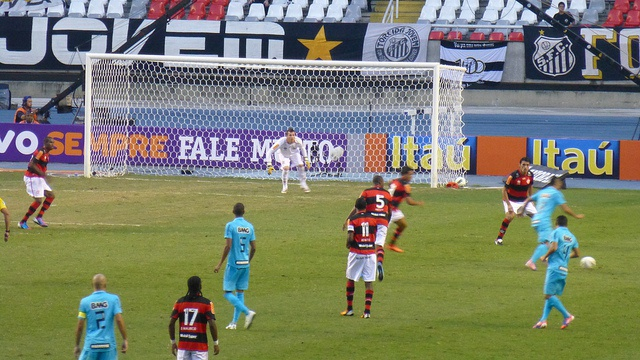Describe the objects in this image and their specific colors. I can see people in tan, black, lavender, maroon, and darkgray tones, people in tan, lightblue, teal, and olive tones, people in tan, teal, and lightblue tones, people in tan, black, brown, olive, and maroon tones, and people in tan, lightblue, and teal tones in this image. 